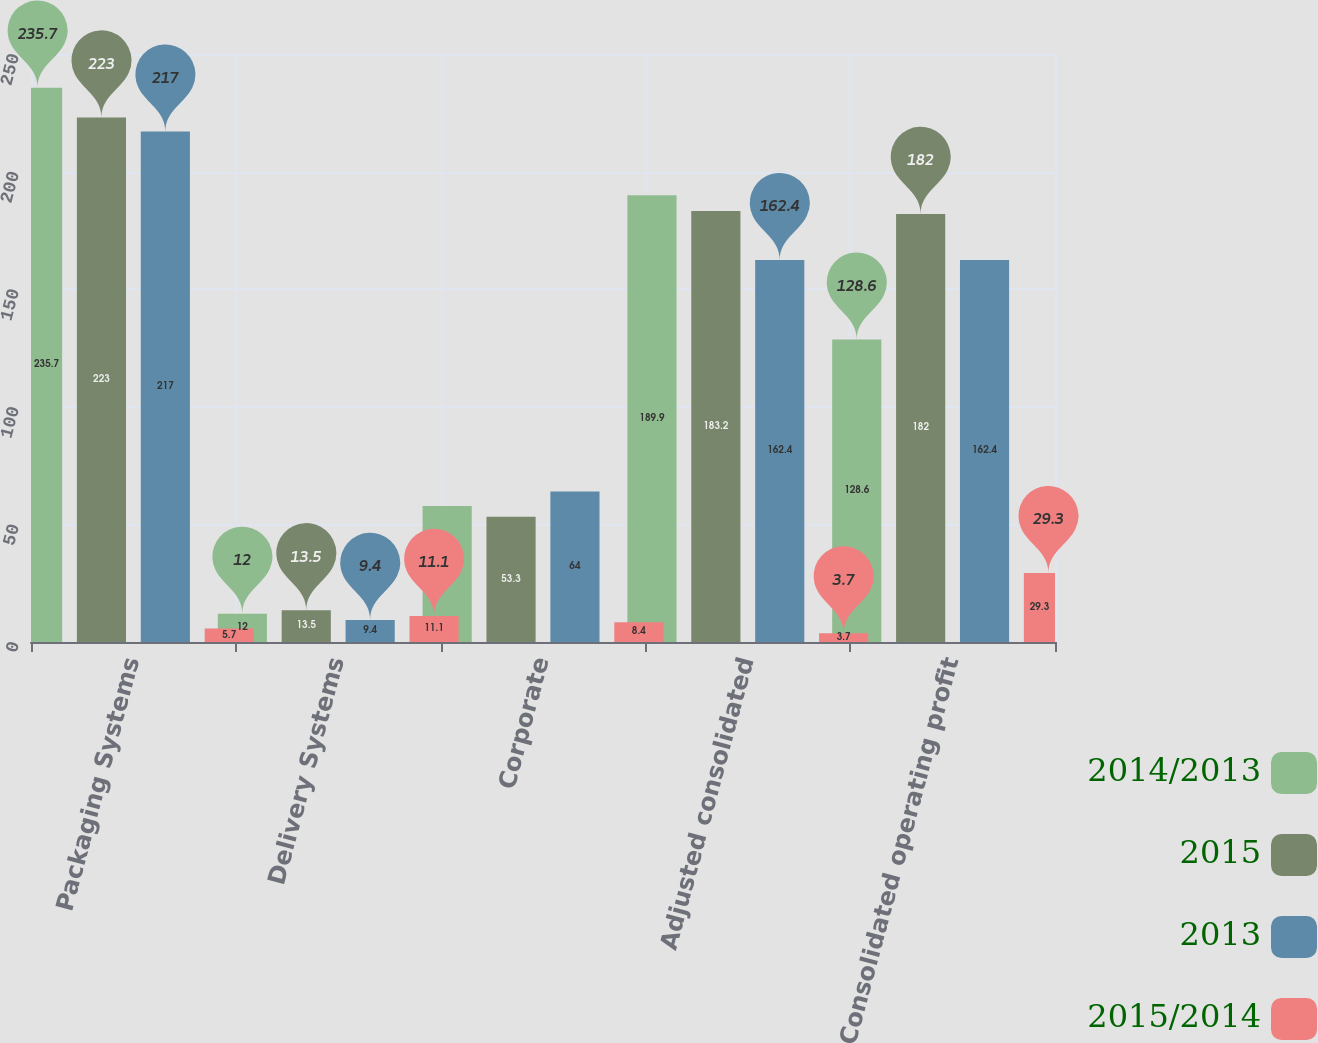<chart> <loc_0><loc_0><loc_500><loc_500><stacked_bar_chart><ecel><fcel>Packaging Systems<fcel>Delivery Systems<fcel>Corporate<fcel>Adjusted consolidated<fcel>Consolidated operating profit<nl><fcel>2014/2013<fcel>235.7<fcel>12<fcel>57.8<fcel>189.9<fcel>128.6<nl><fcel>2015<fcel>223<fcel>13.5<fcel>53.3<fcel>183.2<fcel>182<nl><fcel>2013<fcel>217<fcel>9.4<fcel>64<fcel>162.4<fcel>162.4<nl><fcel>2015/2014<fcel>5.7<fcel>11.1<fcel>8.4<fcel>3.7<fcel>29.3<nl></chart> 